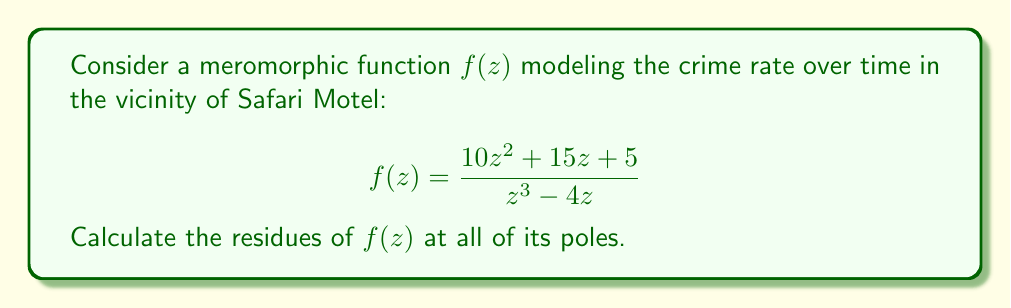Can you answer this question? To find the residues of $f(z)$, we need to:
1. Identify the poles of the function
2. Determine the order of each pole
3. Calculate the residue at each pole

Step 1: Identifying the poles
The poles of $f(z)$ occur where the denominator is zero:
$z^3 - 4z = z(z^2 - 4) = z(z-2)(z+2) = 0$

So, the poles are at $z = 0$, $z = 2$, and $z = -2$.

Step 2: Determining the order of each pole
- At $z = 0$, the denominator has a factor of $z^1$, so it's a simple pole (order 1).
- At $z = 2$ and $z = -2$, the denominator has a factor of $(z-2)^1$ and $(z+2)^1$ respectively, so these are also simple poles.

Step 3: Calculating the residues

For simple poles, we can use the formula:
$$\text{Res}(f,a) = \lim_{z \to a} (z-a)f(z)$$

At $z = 0$:
$$\begin{align*}
\text{Res}(f,0) &= \lim_{z \to 0} z \cdot \frac{10z^2 + 15z + 5}{z^3 - 4z} \\
&= \lim_{z \to 0} \frac{10z^3 + 15z^2 + 5z}{z^3 - 4z} \\
&= \lim_{z \to 0} \frac{10z^2 + 15z + 5}{z^2 - 4} \\
&= \frac{5}{-4} = -\frac{5}{4}
\end{align*}$$

At $z = 2$:
$$\begin{align*}
\text{Res}(f,2) &= \lim_{z \to 2} (z-2) \cdot \frac{10z^2 + 15z + 5}{z^3 - 4z} \\
&= \lim_{z \to 2} \frac{10z^2 + 15z + 5}{z^2 + 2z} \\
&= \frac{10(4) + 15(2) + 5}{4 + 4} \\
&= \frac{55}{8}
\end{align*}$$

At $z = -2$:
$$\begin{align*}
\text{Res}(f,-2) &= \lim_{z \to -2} (z+2) \cdot \frac{10z^2 + 15z + 5}{z^3 - 4z} \\
&= \lim_{z \to -2} \frac{10z^2 + 15z + 5}{z^2 - 2z} \\
&= \frac{10(4) - 15(2) + 5}{4 + 4} \\
&= \frac{15}{8}
\end{align*}$$
Answer: The residues of $f(z)$ are:
- At $z = 0$: $-\frac{5}{4}$
- At $z = 2$: $\frac{55}{8}$
- At $z = -2$: $\frac{15}{8}$ 